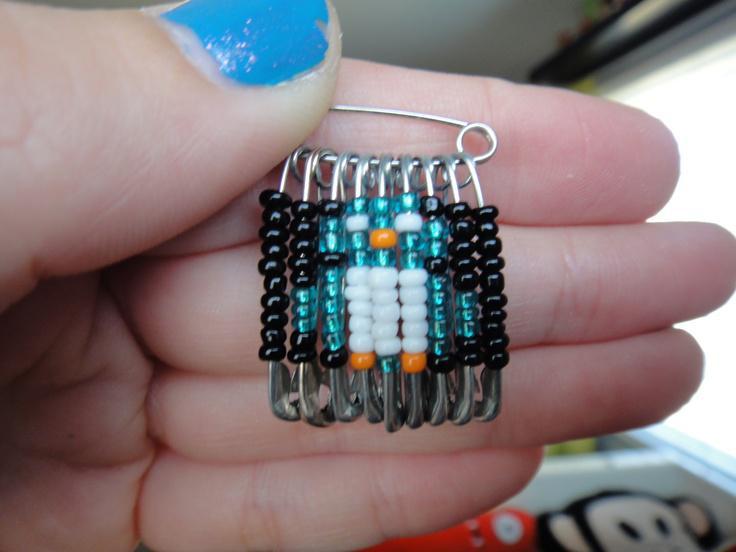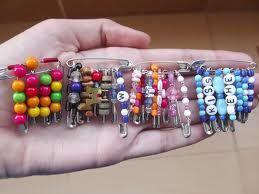The first image is the image on the left, the second image is the image on the right. For the images displayed, is the sentence "An image shows only one decorative pin with a pattern created by dangling pins strung with beads." factually correct? Answer yes or no. Yes. The first image is the image on the left, the second image is the image on the right. Assess this claim about the two images: "A bracelet made of pins is worn on a wrist in the image on the left.". Correct or not? Answer yes or no. No. 